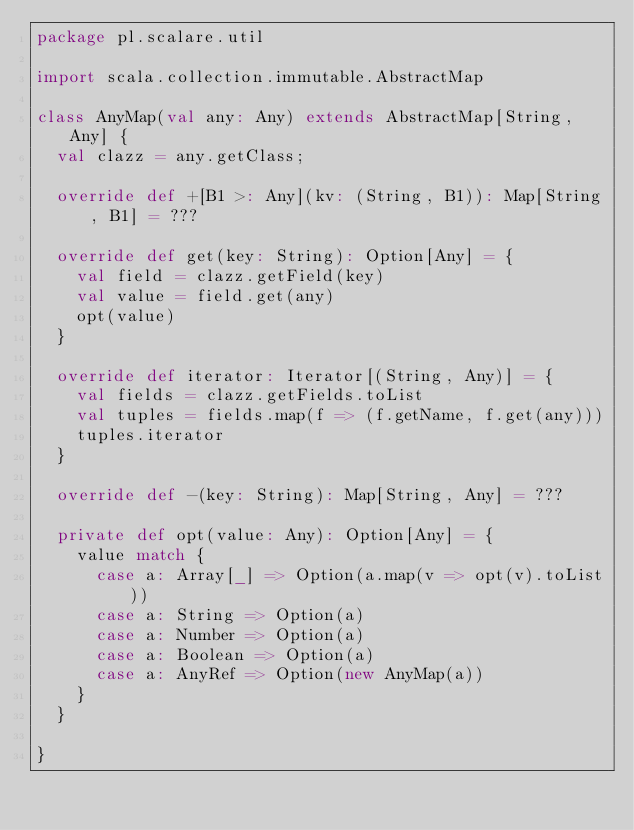<code> <loc_0><loc_0><loc_500><loc_500><_Scala_>package pl.scalare.util

import scala.collection.immutable.AbstractMap

class AnyMap(val any: Any) extends AbstractMap[String, Any] {
  val clazz = any.getClass;

  override def +[B1 >: Any](kv: (String, B1)): Map[String, B1] = ???

  override def get(key: String): Option[Any] = {
    val field = clazz.getField(key)
    val value = field.get(any)
    opt(value)
  }

  override def iterator: Iterator[(String, Any)] = {
    val fields = clazz.getFields.toList
    val tuples = fields.map(f => (f.getName, f.get(any)))
    tuples.iterator
  }

  override def -(key: String): Map[String, Any] = ???

  private def opt(value: Any): Option[Any] = {
    value match {
      case a: Array[_] => Option(a.map(v => opt(v).toList))
      case a: String => Option(a)
      case a: Number => Option(a)
      case a: Boolean => Option(a)
      case a: AnyRef => Option(new AnyMap(a))
    }
  }

}
</code> 